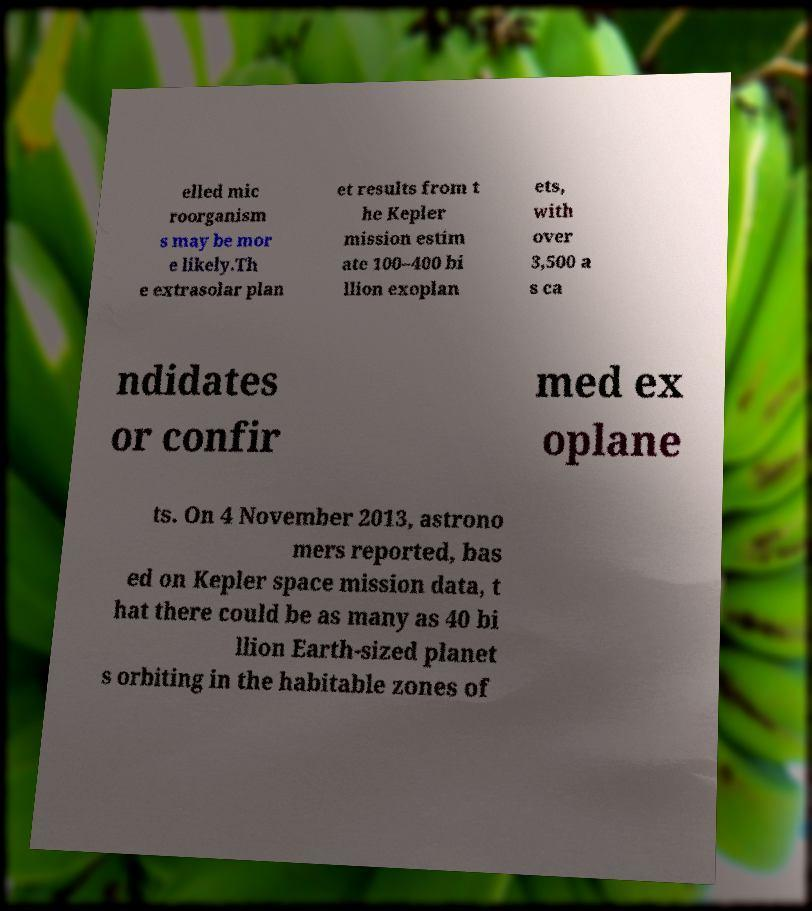Please read and relay the text visible in this image. What does it say? elled mic roorganism s may be mor e likely.Th e extrasolar plan et results from t he Kepler mission estim ate 100–400 bi llion exoplan ets, with over 3,500 a s ca ndidates or confir med ex oplane ts. On 4 November 2013, astrono mers reported, bas ed on Kepler space mission data, t hat there could be as many as 40 bi llion Earth-sized planet s orbiting in the habitable zones of 